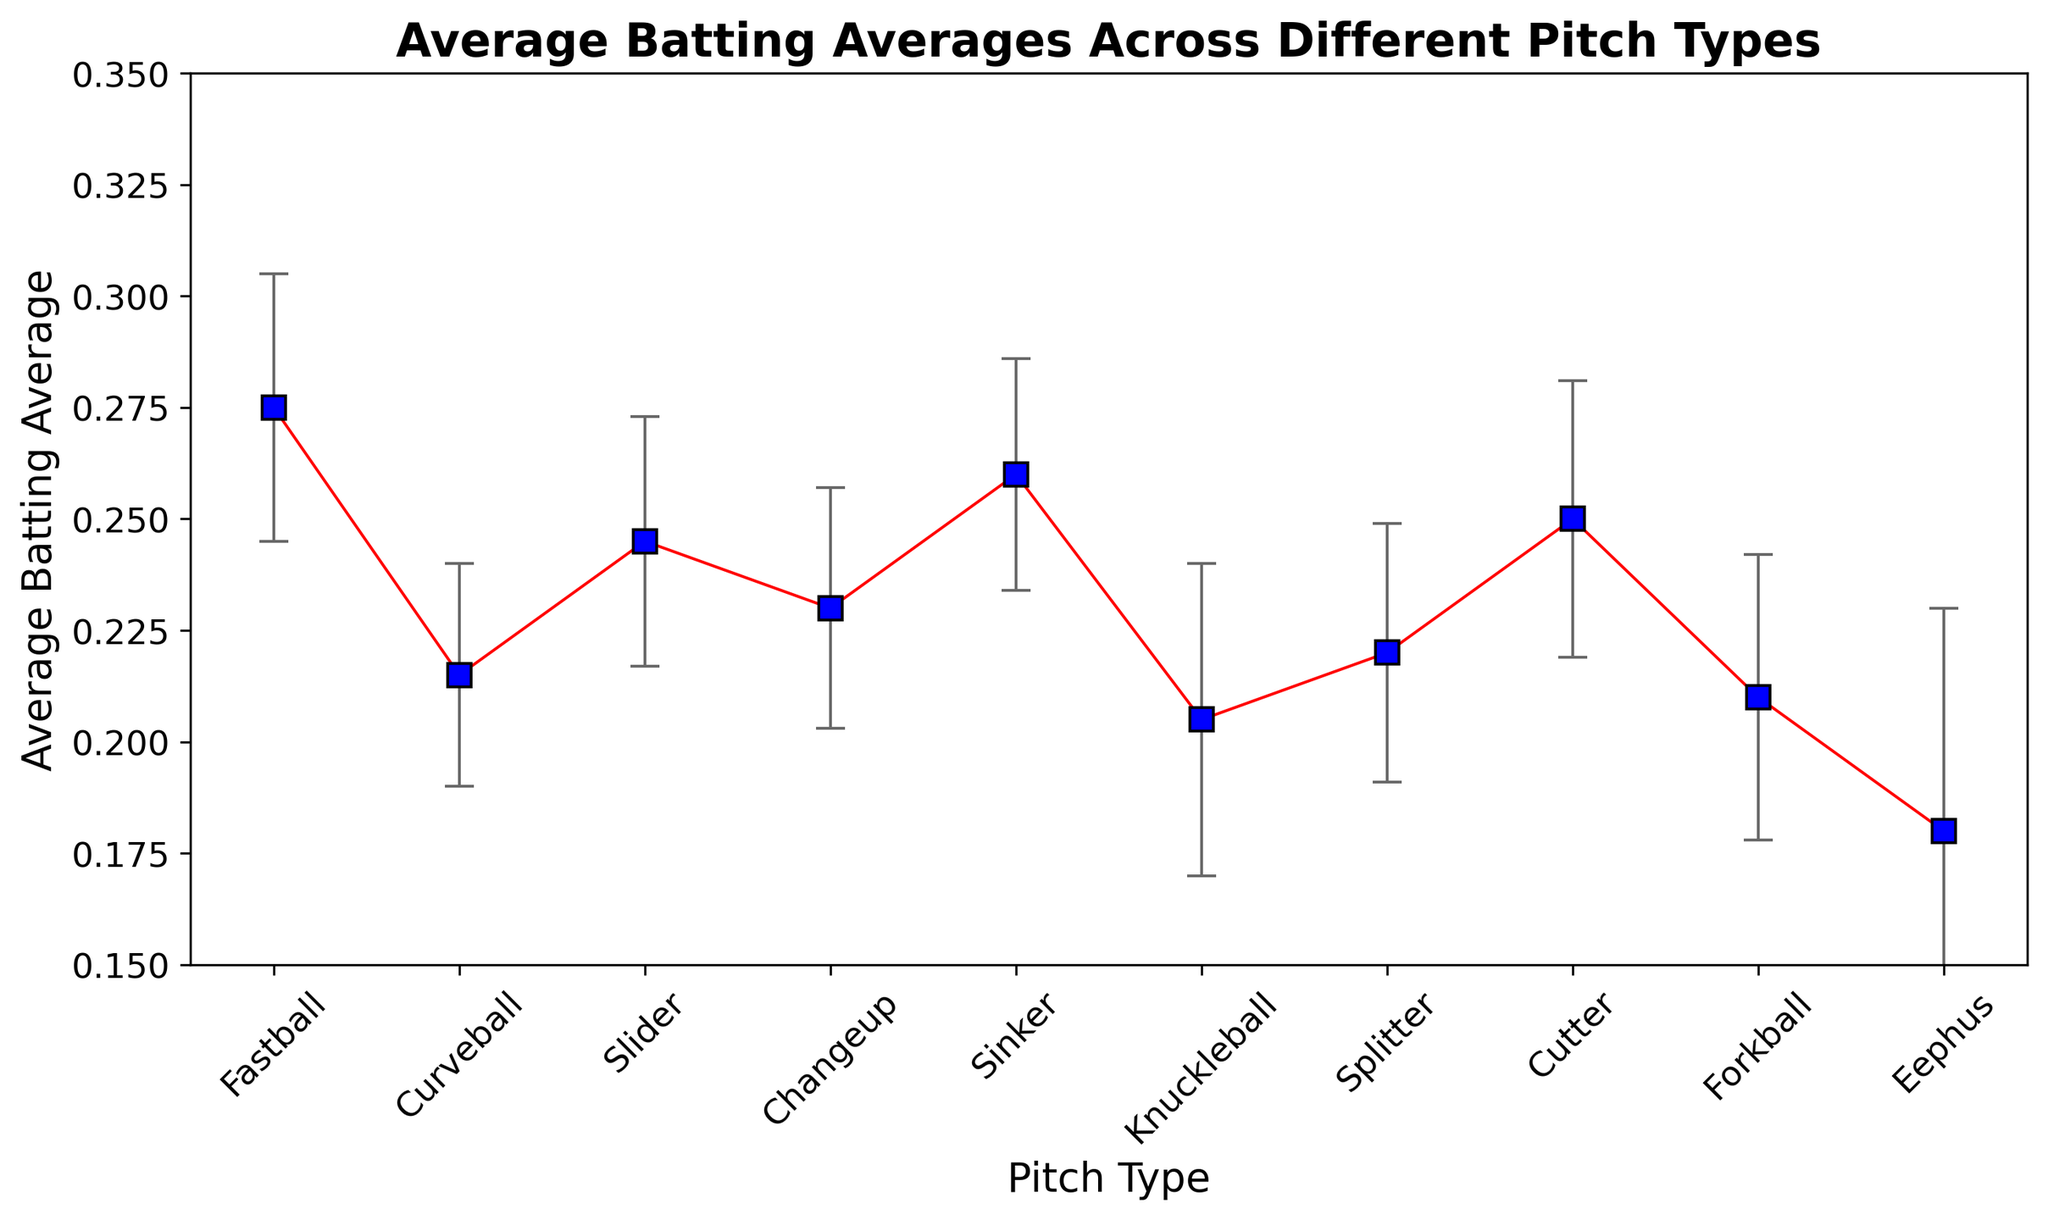What pitch type has the highest average batting average? The pitch types and their average batting averages are plotted in the graph. The Fastball has the highest value indicated near 0.275.
Answer: Fastball What pitch type shows the greatest variability in batting averages? The standard deviation is represented by the length of the error bars. The Eephus pitch has the longest error bars, indicating the greatest variability.
Answer: Eephus How does the average batting average for a Curveball compare to that of a Slider? The Curveball has an average batting average of 0.215, while the Slider has an average of 0.245. Therefore, the batting average against the Slider is higher than against the Curveball.
Answer: Slider is higher Which pitch types have a higher average batting average than the Splitter? The average batting average for the Splitter is 0.220. Fastball (0.275), Sinker (0.260), Cutter (0.250), and Slider (0.245) are all higher than 0.220.
Answer: Fastball, Sinker, Cutter, Slider What is the difference in average batting average between a Knuckleball and a Cutter? The average batting average for a Knuckleball is 0.205 and for a Cutter it is 0.250. The difference is 0.250 - 0.205 = 0.045.
Answer: 0.045 Which pitch type offers the least chance for a hit based on the average batting average? The smallest batting average is desired for the least chance of a hit. That's for the Eephus pitch with an average batting average of 0.180.
Answer: Eephus How does the standard deviation for the Fastball compare to that of the Forkball? The standard deviation for the Fastball is 0.030 while for the Forkball it is 0.032. The Forkball has a slightly higher standard deviation.
Answer: Forkball is higher What is the average of the average batting averages for all pitch types? Sum all the average batting averages: (0.275 + 0.215 + 0.245 + 0.230 + 0.260 + 0.205 + 0.220 + 0.250 + 0.210 + 0.180) = 2.29. There are 10 pitch types, so the average is 2.29 / 10 = 0.229.
Answer: 0.229 If a player improves their batting average against Changeups by 0.010, what would their new average be? The current average batting average for Changeups is 0.230. Improving it by 0.010 results in 0.230 + 0.010 = 0.240.
Answer: 0.240 